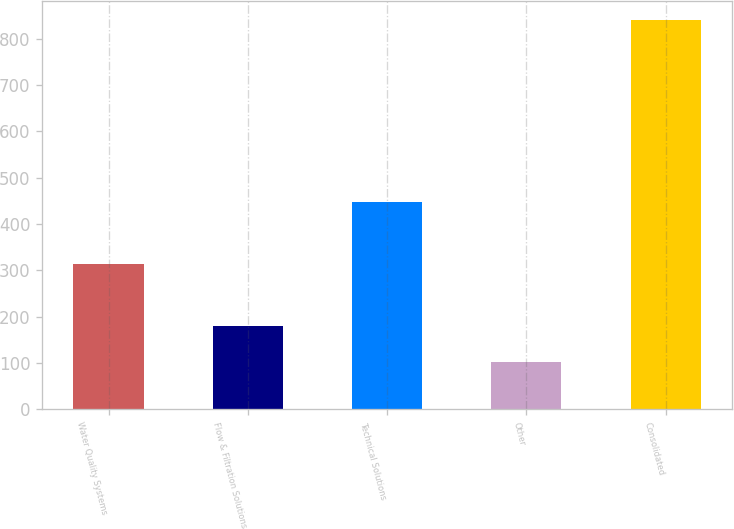<chart> <loc_0><loc_0><loc_500><loc_500><bar_chart><fcel>Water Quality Systems<fcel>Flow & Filtration Solutions<fcel>Technical Solutions<fcel>Other<fcel>Consolidated<nl><fcel>313.3<fcel>180.7<fcel>447.2<fcel>101.7<fcel>839.5<nl></chart> 